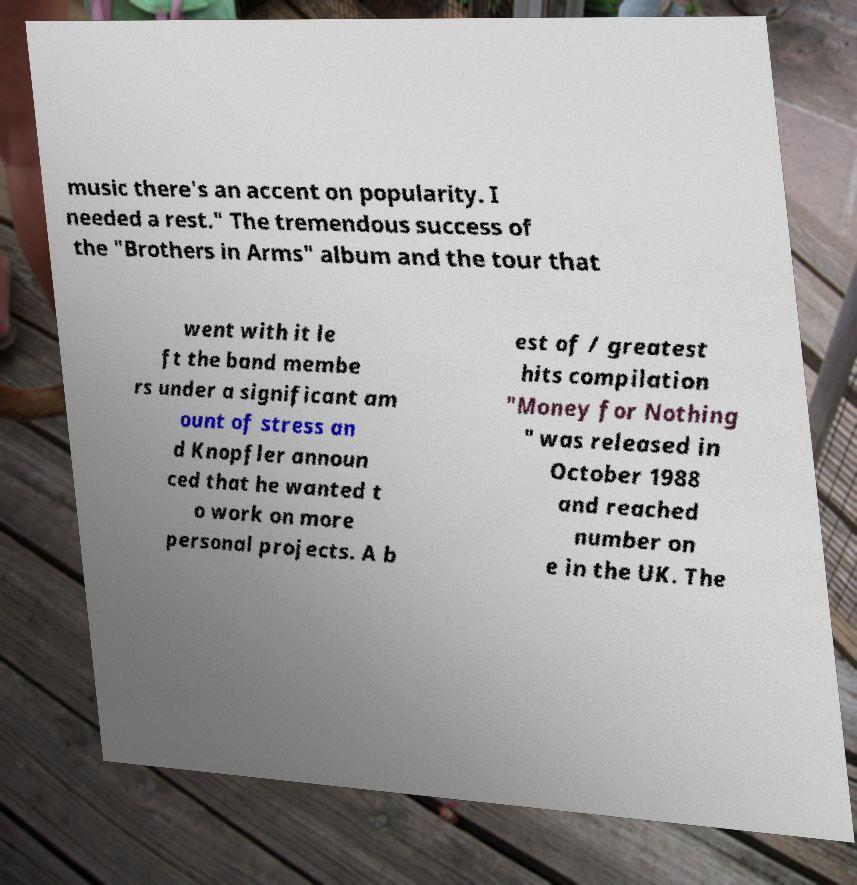What messages or text are displayed in this image? I need them in a readable, typed format. music there's an accent on popularity. I needed a rest." The tremendous success of the "Brothers in Arms" album and the tour that went with it le ft the band membe rs under a significant am ount of stress an d Knopfler announ ced that he wanted t o work on more personal projects. A b est of / greatest hits compilation "Money for Nothing " was released in October 1988 and reached number on e in the UK. The 